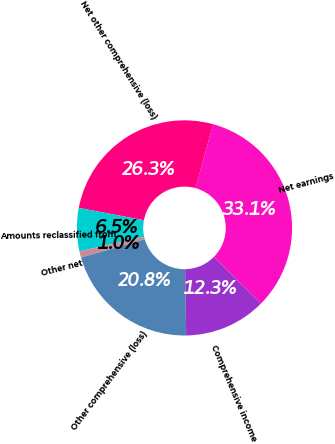Convert chart. <chart><loc_0><loc_0><loc_500><loc_500><pie_chart><fcel>Net earnings<fcel>Net other comprehensive (loss)<fcel>Amounts reclassified from<fcel>Other net<fcel>Other comprehensive (loss)<fcel>Comprehensive income<nl><fcel>33.13%<fcel>26.31%<fcel>6.47%<fcel>0.96%<fcel>20.8%<fcel>12.33%<nl></chart> 